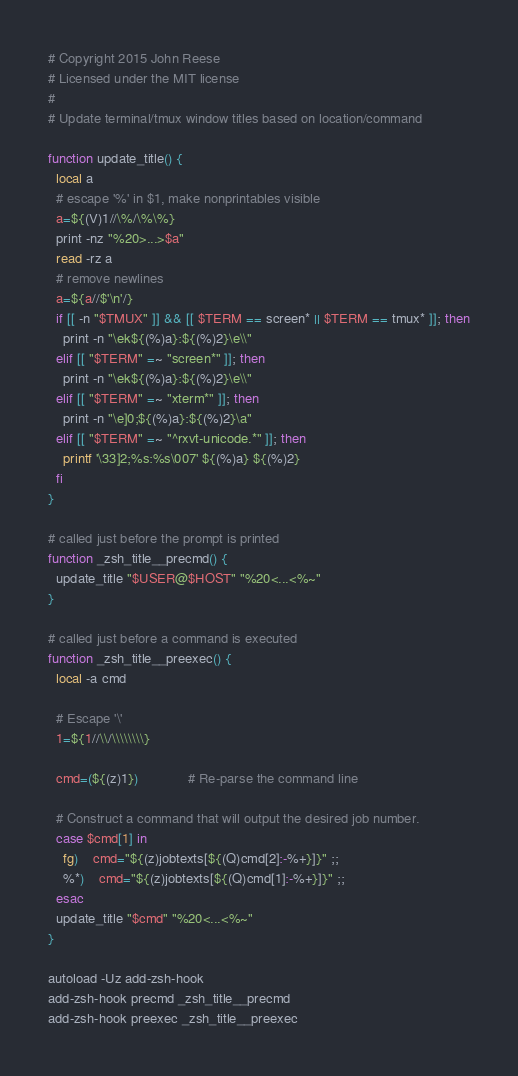Convert code to text. <code><loc_0><loc_0><loc_500><loc_500><_Bash_># Copyright 2015 John Reese
# Licensed under the MIT license
#
# Update terminal/tmux window titles based on location/command

function update_title() {
  local a
  # escape '%' in $1, make nonprintables visible
  a=${(V)1//\%/\%\%}
  print -nz "%20>...>$a"
  read -rz a
  # remove newlines
  a=${a//$'\n'/}
  if [[ -n "$TMUX" ]] && [[ $TERM == screen* || $TERM == tmux* ]]; then
    print -n "\ek${(%)a}:${(%)2}\e\\"
  elif [[ "$TERM" =~ "screen*" ]]; then
    print -n "\ek${(%)a}:${(%)2}\e\\"
  elif [[ "$TERM" =~ "xterm*" ]]; then
    print -n "\e]0;${(%)a}:${(%)2}\a"
  elif [[ "$TERM" =~ "^rxvt-unicode.*" ]]; then
    printf '\33]2;%s:%s\007' ${(%)a} ${(%)2}
  fi
}

# called just before the prompt is printed
function _zsh_title__precmd() {
  update_title "$USER@$HOST" "%20<...<%~"
}

# called just before a command is executed
function _zsh_title__preexec() {
  local -a cmd

  # Escape '\'
  1=${1//\\/\\\\\\\\}

  cmd=(${(z)1})             # Re-parse the command line

  # Construct a command that will output the desired job number.
  case $cmd[1] in
    fg)	cmd="${(z)jobtexts[${(Q)cmd[2]:-%+}]}" ;;
    %*)	cmd="${(z)jobtexts[${(Q)cmd[1]:-%+}]}" ;;
  esac
  update_title "$cmd" "%20<...<%~"
}

autoload -Uz add-zsh-hook
add-zsh-hook precmd _zsh_title__precmd
add-zsh-hook preexec _zsh_title__preexec
</code> 